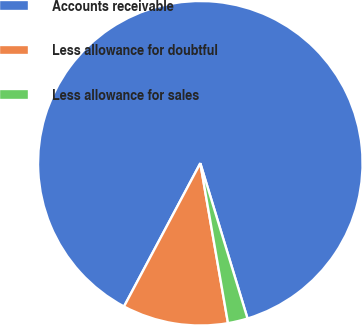Convert chart. <chart><loc_0><loc_0><loc_500><loc_500><pie_chart><fcel>Accounts receivable<fcel>Less allowance for doubtful<fcel>Less allowance for sales<nl><fcel>87.51%<fcel>10.52%<fcel>1.97%<nl></chart> 